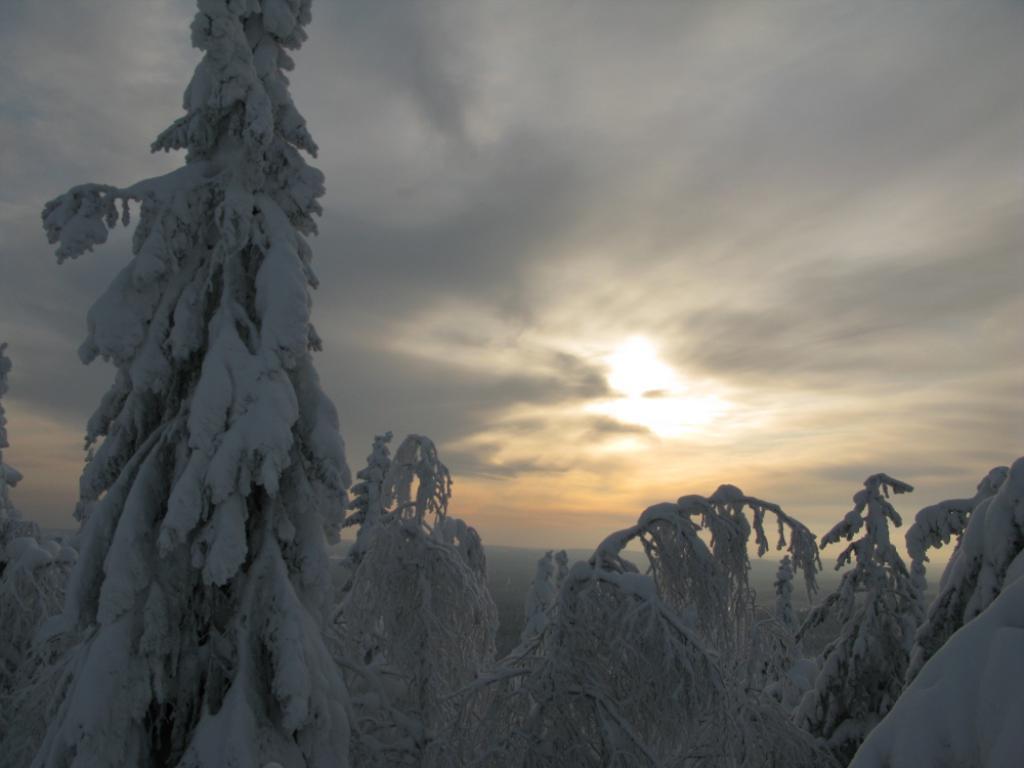How would you summarize this image in a sentence or two? These are the trees with the snow and this is the sky. 